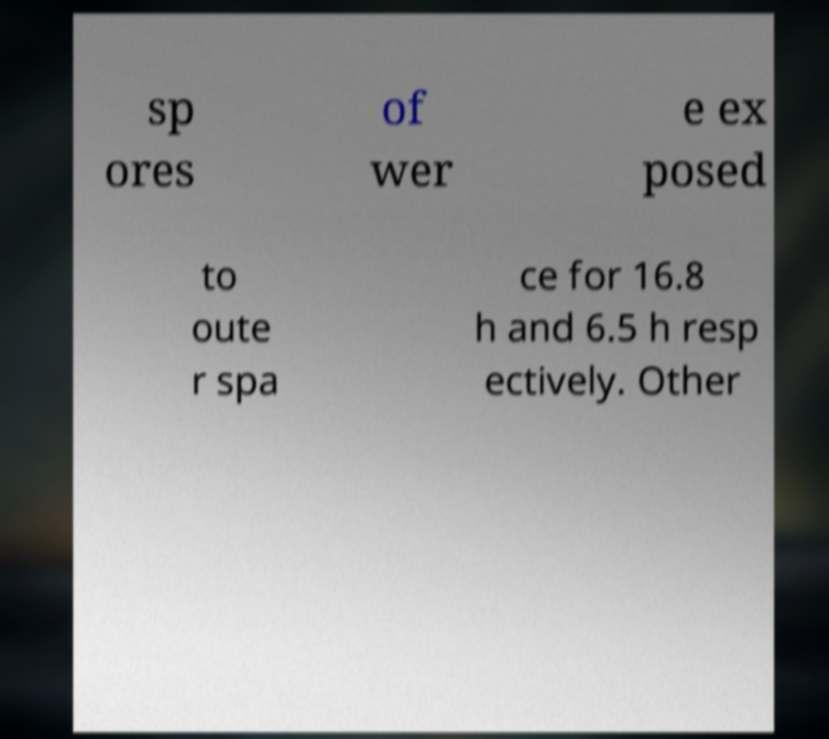Can you accurately transcribe the text from the provided image for me? sp ores of wer e ex posed to oute r spa ce for 16.8 h and 6.5 h resp ectively. Other 